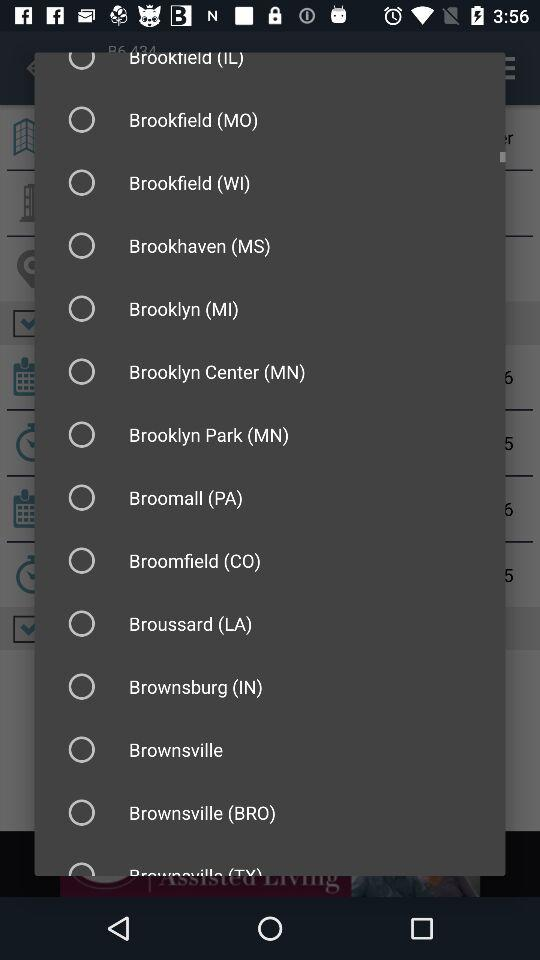What day is it on the 12th? The day is Friday. 